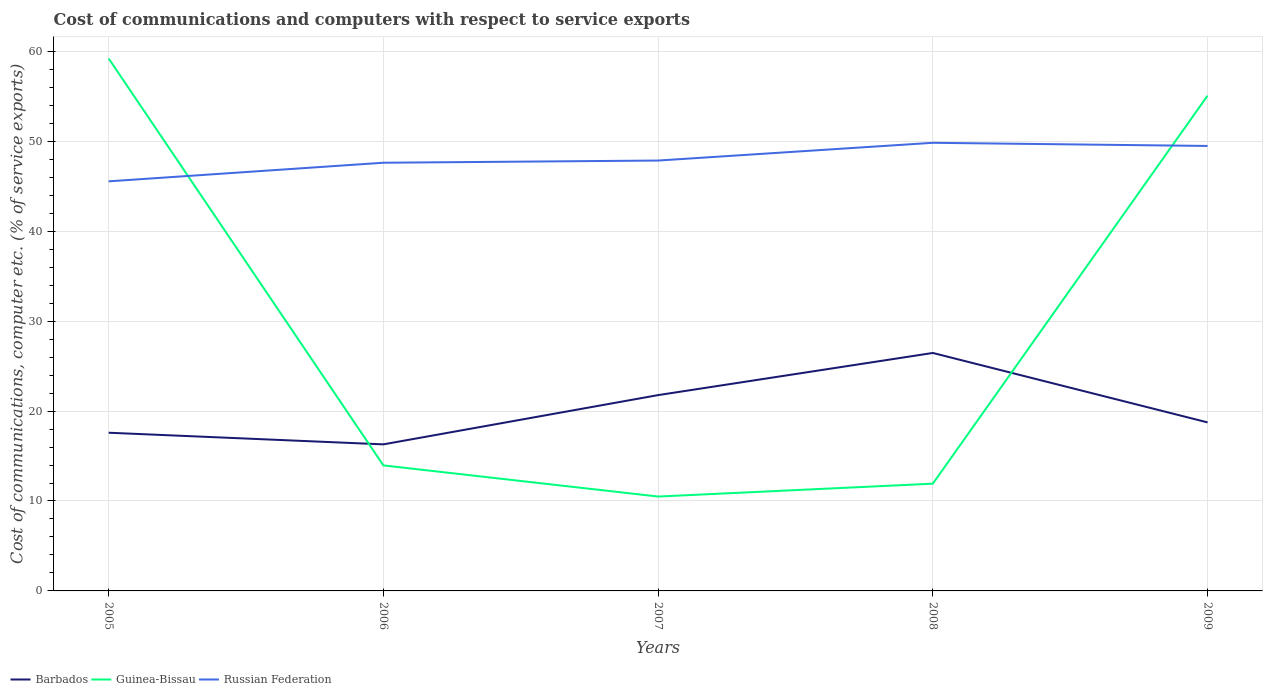How many different coloured lines are there?
Provide a succinct answer. 3. Across all years, what is the maximum cost of communications and computers in Guinea-Bissau?
Your response must be concise. 10.49. What is the total cost of communications and computers in Guinea-Bissau in the graph?
Provide a succinct answer. -1.43. What is the difference between the highest and the second highest cost of communications and computers in Barbados?
Your answer should be very brief. 10.16. What is the difference between the highest and the lowest cost of communications and computers in Russian Federation?
Ensure brevity in your answer.  2. Is the cost of communications and computers in Russian Federation strictly greater than the cost of communications and computers in Barbados over the years?
Your response must be concise. No. How many lines are there?
Offer a terse response. 3. What is the difference between two consecutive major ticks on the Y-axis?
Offer a terse response. 10. Does the graph contain any zero values?
Provide a short and direct response. No. Where does the legend appear in the graph?
Offer a terse response. Bottom left. How many legend labels are there?
Keep it short and to the point. 3. How are the legend labels stacked?
Ensure brevity in your answer.  Horizontal. What is the title of the graph?
Ensure brevity in your answer.  Cost of communications and computers with respect to service exports. Does "Guam" appear as one of the legend labels in the graph?
Offer a very short reply. No. What is the label or title of the X-axis?
Your answer should be compact. Years. What is the label or title of the Y-axis?
Your answer should be very brief. Cost of communications, computer etc. (% of service exports). What is the Cost of communications, computer etc. (% of service exports) in Barbados in 2005?
Keep it short and to the point. 17.59. What is the Cost of communications, computer etc. (% of service exports) of Guinea-Bissau in 2005?
Offer a terse response. 59.21. What is the Cost of communications, computer etc. (% of service exports) of Russian Federation in 2005?
Make the answer very short. 45.55. What is the Cost of communications, computer etc. (% of service exports) in Barbados in 2006?
Offer a very short reply. 16.3. What is the Cost of communications, computer etc. (% of service exports) of Guinea-Bissau in 2006?
Your answer should be compact. 13.96. What is the Cost of communications, computer etc. (% of service exports) of Russian Federation in 2006?
Ensure brevity in your answer.  47.61. What is the Cost of communications, computer etc. (% of service exports) of Barbados in 2007?
Provide a short and direct response. 21.77. What is the Cost of communications, computer etc. (% of service exports) in Guinea-Bissau in 2007?
Make the answer very short. 10.49. What is the Cost of communications, computer etc. (% of service exports) of Russian Federation in 2007?
Provide a succinct answer. 47.86. What is the Cost of communications, computer etc. (% of service exports) in Barbados in 2008?
Ensure brevity in your answer.  26.46. What is the Cost of communications, computer etc. (% of service exports) of Guinea-Bissau in 2008?
Your answer should be very brief. 11.93. What is the Cost of communications, computer etc. (% of service exports) of Russian Federation in 2008?
Your response must be concise. 49.83. What is the Cost of communications, computer etc. (% of service exports) in Barbados in 2009?
Provide a succinct answer. 18.74. What is the Cost of communications, computer etc. (% of service exports) in Guinea-Bissau in 2009?
Your answer should be compact. 55.07. What is the Cost of communications, computer etc. (% of service exports) in Russian Federation in 2009?
Offer a very short reply. 49.48. Across all years, what is the maximum Cost of communications, computer etc. (% of service exports) of Barbados?
Keep it short and to the point. 26.46. Across all years, what is the maximum Cost of communications, computer etc. (% of service exports) of Guinea-Bissau?
Your answer should be compact. 59.21. Across all years, what is the maximum Cost of communications, computer etc. (% of service exports) in Russian Federation?
Your answer should be very brief. 49.83. Across all years, what is the minimum Cost of communications, computer etc. (% of service exports) of Barbados?
Offer a terse response. 16.3. Across all years, what is the minimum Cost of communications, computer etc. (% of service exports) of Guinea-Bissau?
Provide a short and direct response. 10.49. Across all years, what is the minimum Cost of communications, computer etc. (% of service exports) in Russian Federation?
Your answer should be compact. 45.55. What is the total Cost of communications, computer etc. (% of service exports) of Barbados in the graph?
Ensure brevity in your answer.  100.86. What is the total Cost of communications, computer etc. (% of service exports) in Guinea-Bissau in the graph?
Offer a terse response. 150.66. What is the total Cost of communications, computer etc. (% of service exports) of Russian Federation in the graph?
Give a very brief answer. 240.33. What is the difference between the Cost of communications, computer etc. (% of service exports) of Barbados in 2005 and that in 2006?
Give a very brief answer. 1.29. What is the difference between the Cost of communications, computer etc. (% of service exports) in Guinea-Bissau in 2005 and that in 2006?
Give a very brief answer. 45.25. What is the difference between the Cost of communications, computer etc. (% of service exports) of Russian Federation in 2005 and that in 2006?
Offer a very short reply. -2.07. What is the difference between the Cost of communications, computer etc. (% of service exports) of Barbados in 2005 and that in 2007?
Provide a short and direct response. -4.18. What is the difference between the Cost of communications, computer etc. (% of service exports) of Guinea-Bissau in 2005 and that in 2007?
Your answer should be very brief. 48.71. What is the difference between the Cost of communications, computer etc. (% of service exports) of Russian Federation in 2005 and that in 2007?
Make the answer very short. -2.31. What is the difference between the Cost of communications, computer etc. (% of service exports) of Barbados in 2005 and that in 2008?
Your answer should be very brief. -8.87. What is the difference between the Cost of communications, computer etc. (% of service exports) in Guinea-Bissau in 2005 and that in 2008?
Make the answer very short. 47.28. What is the difference between the Cost of communications, computer etc. (% of service exports) in Russian Federation in 2005 and that in 2008?
Offer a terse response. -4.28. What is the difference between the Cost of communications, computer etc. (% of service exports) in Barbados in 2005 and that in 2009?
Make the answer very short. -1.15. What is the difference between the Cost of communications, computer etc. (% of service exports) of Guinea-Bissau in 2005 and that in 2009?
Your response must be concise. 4.14. What is the difference between the Cost of communications, computer etc. (% of service exports) of Russian Federation in 2005 and that in 2009?
Provide a short and direct response. -3.93. What is the difference between the Cost of communications, computer etc. (% of service exports) of Barbados in 2006 and that in 2007?
Ensure brevity in your answer.  -5.48. What is the difference between the Cost of communications, computer etc. (% of service exports) of Guinea-Bissau in 2006 and that in 2007?
Your answer should be compact. 3.46. What is the difference between the Cost of communications, computer etc. (% of service exports) in Russian Federation in 2006 and that in 2007?
Your response must be concise. -0.24. What is the difference between the Cost of communications, computer etc. (% of service exports) in Barbados in 2006 and that in 2008?
Offer a very short reply. -10.16. What is the difference between the Cost of communications, computer etc. (% of service exports) of Guinea-Bissau in 2006 and that in 2008?
Give a very brief answer. 2.03. What is the difference between the Cost of communications, computer etc. (% of service exports) in Russian Federation in 2006 and that in 2008?
Give a very brief answer. -2.22. What is the difference between the Cost of communications, computer etc. (% of service exports) in Barbados in 2006 and that in 2009?
Keep it short and to the point. -2.44. What is the difference between the Cost of communications, computer etc. (% of service exports) of Guinea-Bissau in 2006 and that in 2009?
Your answer should be compact. -41.11. What is the difference between the Cost of communications, computer etc. (% of service exports) of Russian Federation in 2006 and that in 2009?
Your answer should be compact. -1.87. What is the difference between the Cost of communications, computer etc. (% of service exports) in Barbados in 2007 and that in 2008?
Offer a terse response. -4.69. What is the difference between the Cost of communications, computer etc. (% of service exports) in Guinea-Bissau in 2007 and that in 2008?
Provide a succinct answer. -1.43. What is the difference between the Cost of communications, computer etc. (% of service exports) of Russian Federation in 2007 and that in 2008?
Provide a short and direct response. -1.97. What is the difference between the Cost of communications, computer etc. (% of service exports) of Barbados in 2007 and that in 2009?
Make the answer very short. 3.03. What is the difference between the Cost of communications, computer etc. (% of service exports) in Guinea-Bissau in 2007 and that in 2009?
Keep it short and to the point. -44.58. What is the difference between the Cost of communications, computer etc. (% of service exports) of Russian Federation in 2007 and that in 2009?
Your answer should be very brief. -1.62. What is the difference between the Cost of communications, computer etc. (% of service exports) in Barbados in 2008 and that in 2009?
Make the answer very short. 7.72. What is the difference between the Cost of communications, computer etc. (% of service exports) in Guinea-Bissau in 2008 and that in 2009?
Make the answer very short. -43.15. What is the difference between the Cost of communications, computer etc. (% of service exports) in Russian Federation in 2008 and that in 2009?
Keep it short and to the point. 0.35. What is the difference between the Cost of communications, computer etc. (% of service exports) in Barbados in 2005 and the Cost of communications, computer etc. (% of service exports) in Guinea-Bissau in 2006?
Your answer should be very brief. 3.63. What is the difference between the Cost of communications, computer etc. (% of service exports) of Barbados in 2005 and the Cost of communications, computer etc. (% of service exports) of Russian Federation in 2006?
Provide a succinct answer. -30.02. What is the difference between the Cost of communications, computer etc. (% of service exports) of Guinea-Bissau in 2005 and the Cost of communications, computer etc. (% of service exports) of Russian Federation in 2006?
Offer a terse response. 11.59. What is the difference between the Cost of communications, computer etc. (% of service exports) in Barbados in 2005 and the Cost of communications, computer etc. (% of service exports) in Guinea-Bissau in 2007?
Make the answer very short. 7.1. What is the difference between the Cost of communications, computer etc. (% of service exports) of Barbados in 2005 and the Cost of communications, computer etc. (% of service exports) of Russian Federation in 2007?
Offer a terse response. -30.27. What is the difference between the Cost of communications, computer etc. (% of service exports) in Guinea-Bissau in 2005 and the Cost of communications, computer etc. (% of service exports) in Russian Federation in 2007?
Keep it short and to the point. 11.35. What is the difference between the Cost of communications, computer etc. (% of service exports) of Barbados in 2005 and the Cost of communications, computer etc. (% of service exports) of Guinea-Bissau in 2008?
Provide a succinct answer. 5.67. What is the difference between the Cost of communications, computer etc. (% of service exports) in Barbados in 2005 and the Cost of communications, computer etc. (% of service exports) in Russian Federation in 2008?
Keep it short and to the point. -32.24. What is the difference between the Cost of communications, computer etc. (% of service exports) of Guinea-Bissau in 2005 and the Cost of communications, computer etc. (% of service exports) of Russian Federation in 2008?
Offer a terse response. 9.38. What is the difference between the Cost of communications, computer etc. (% of service exports) of Barbados in 2005 and the Cost of communications, computer etc. (% of service exports) of Guinea-Bissau in 2009?
Your answer should be compact. -37.48. What is the difference between the Cost of communications, computer etc. (% of service exports) of Barbados in 2005 and the Cost of communications, computer etc. (% of service exports) of Russian Federation in 2009?
Provide a succinct answer. -31.89. What is the difference between the Cost of communications, computer etc. (% of service exports) in Guinea-Bissau in 2005 and the Cost of communications, computer etc. (% of service exports) in Russian Federation in 2009?
Provide a succinct answer. 9.73. What is the difference between the Cost of communications, computer etc. (% of service exports) in Barbados in 2006 and the Cost of communications, computer etc. (% of service exports) in Guinea-Bissau in 2007?
Your answer should be compact. 5.8. What is the difference between the Cost of communications, computer etc. (% of service exports) in Barbados in 2006 and the Cost of communications, computer etc. (% of service exports) in Russian Federation in 2007?
Offer a very short reply. -31.56. What is the difference between the Cost of communications, computer etc. (% of service exports) in Guinea-Bissau in 2006 and the Cost of communications, computer etc. (% of service exports) in Russian Federation in 2007?
Offer a terse response. -33.9. What is the difference between the Cost of communications, computer etc. (% of service exports) in Barbados in 2006 and the Cost of communications, computer etc. (% of service exports) in Guinea-Bissau in 2008?
Give a very brief answer. 4.37. What is the difference between the Cost of communications, computer etc. (% of service exports) of Barbados in 2006 and the Cost of communications, computer etc. (% of service exports) of Russian Federation in 2008?
Make the answer very short. -33.53. What is the difference between the Cost of communications, computer etc. (% of service exports) in Guinea-Bissau in 2006 and the Cost of communications, computer etc. (% of service exports) in Russian Federation in 2008?
Make the answer very short. -35.87. What is the difference between the Cost of communications, computer etc. (% of service exports) of Barbados in 2006 and the Cost of communications, computer etc. (% of service exports) of Guinea-Bissau in 2009?
Make the answer very short. -38.78. What is the difference between the Cost of communications, computer etc. (% of service exports) in Barbados in 2006 and the Cost of communications, computer etc. (% of service exports) in Russian Federation in 2009?
Provide a succinct answer. -33.18. What is the difference between the Cost of communications, computer etc. (% of service exports) in Guinea-Bissau in 2006 and the Cost of communications, computer etc. (% of service exports) in Russian Federation in 2009?
Ensure brevity in your answer.  -35.52. What is the difference between the Cost of communications, computer etc. (% of service exports) of Barbados in 2007 and the Cost of communications, computer etc. (% of service exports) of Guinea-Bissau in 2008?
Provide a short and direct response. 9.85. What is the difference between the Cost of communications, computer etc. (% of service exports) in Barbados in 2007 and the Cost of communications, computer etc. (% of service exports) in Russian Federation in 2008?
Make the answer very short. -28.06. What is the difference between the Cost of communications, computer etc. (% of service exports) in Guinea-Bissau in 2007 and the Cost of communications, computer etc. (% of service exports) in Russian Federation in 2008?
Provide a succinct answer. -39.34. What is the difference between the Cost of communications, computer etc. (% of service exports) in Barbados in 2007 and the Cost of communications, computer etc. (% of service exports) in Guinea-Bissau in 2009?
Ensure brevity in your answer.  -33.3. What is the difference between the Cost of communications, computer etc. (% of service exports) in Barbados in 2007 and the Cost of communications, computer etc. (% of service exports) in Russian Federation in 2009?
Your answer should be very brief. -27.71. What is the difference between the Cost of communications, computer etc. (% of service exports) in Guinea-Bissau in 2007 and the Cost of communications, computer etc. (% of service exports) in Russian Federation in 2009?
Your answer should be compact. -38.99. What is the difference between the Cost of communications, computer etc. (% of service exports) of Barbados in 2008 and the Cost of communications, computer etc. (% of service exports) of Guinea-Bissau in 2009?
Your response must be concise. -28.61. What is the difference between the Cost of communications, computer etc. (% of service exports) of Barbados in 2008 and the Cost of communications, computer etc. (% of service exports) of Russian Federation in 2009?
Provide a succinct answer. -23.02. What is the difference between the Cost of communications, computer etc. (% of service exports) in Guinea-Bissau in 2008 and the Cost of communications, computer etc. (% of service exports) in Russian Federation in 2009?
Ensure brevity in your answer.  -37.55. What is the average Cost of communications, computer etc. (% of service exports) in Barbados per year?
Provide a succinct answer. 20.17. What is the average Cost of communications, computer etc. (% of service exports) in Guinea-Bissau per year?
Offer a very short reply. 30.13. What is the average Cost of communications, computer etc. (% of service exports) of Russian Federation per year?
Your answer should be compact. 48.07. In the year 2005, what is the difference between the Cost of communications, computer etc. (% of service exports) of Barbados and Cost of communications, computer etc. (% of service exports) of Guinea-Bissau?
Your answer should be very brief. -41.62. In the year 2005, what is the difference between the Cost of communications, computer etc. (% of service exports) in Barbados and Cost of communications, computer etc. (% of service exports) in Russian Federation?
Offer a very short reply. -27.96. In the year 2005, what is the difference between the Cost of communications, computer etc. (% of service exports) in Guinea-Bissau and Cost of communications, computer etc. (% of service exports) in Russian Federation?
Offer a terse response. 13.66. In the year 2006, what is the difference between the Cost of communications, computer etc. (% of service exports) in Barbados and Cost of communications, computer etc. (% of service exports) in Guinea-Bissau?
Provide a succinct answer. 2.34. In the year 2006, what is the difference between the Cost of communications, computer etc. (% of service exports) of Barbados and Cost of communications, computer etc. (% of service exports) of Russian Federation?
Your response must be concise. -31.32. In the year 2006, what is the difference between the Cost of communications, computer etc. (% of service exports) in Guinea-Bissau and Cost of communications, computer etc. (% of service exports) in Russian Federation?
Make the answer very short. -33.66. In the year 2007, what is the difference between the Cost of communications, computer etc. (% of service exports) in Barbados and Cost of communications, computer etc. (% of service exports) in Guinea-Bissau?
Keep it short and to the point. 11.28. In the year 2007, what is the difference between the Cost of communications, computer etc. (% of service exports) of Barbados and Cost of communications, computer etc. (% of service exports) of Russian Federation?
Offer a very short reply. -26.08. In the year 2007, what is the difference between the Cost of communications, computer etc. (% of service exports) of Guinea-Bissau and Cost of communications, computer etc. (% of service exports) of Russian Federation?
Keep it short and to the point. -37.36. In the year 2008, what is the difference between the Cost of communications, computer etc. (% of service exports) of Barbados and Cost of communications, computer etc. (% of service exports) of Guinea-Bissau?
Make the answer very short. 14.54. In the year 2008, what is the difference between the Cost of communications, computer etc. (% of service exports) of Barbados and Cost of communications, computer etc. (% of service exports) of Russian Federation?
Make the answer very short. -23.37. In the year 2008, what is the difference between the Cost of communications, computer etc. (% of service exports) of Guinea-Bissau and Cost of communications, computer etc. (% of service exports) of Russian Federation?
Keep it short and to the point. -37.9. In the year 2009, what is the difference between the Cost of communications, computer etc. (% of service exports) of Barbados and Cost of communications, computer etc. (% of service exports) of Guinea-Bissau?
Your answer should be compact. -36.33. In the year 2009, what is the difference between the Cost of communications, computer etc. (% of service exports) in Barbados and Cost of communications, computer etc. (% of service exports) in Russian Federation?
Offer a terse response. -30.74. In the year 2009, what is the difference between the Cost of communications, computer etc. (% of service exports) of Guinea-Bissau and Cost of communications, computer etc. (% of service exports) of Russian Federation?
Your answer should be very brief. 5.59. What is the ratio of the Cost of communications, computer etc. (% of service exports) of Barbados in 2005 to that in 2006?
Offer a terse response. 1.08. What is the ratio of the Cost of communications, computer etc. (% of service exports) of Guinea-Bissau in 2005 to that in 2006?
Keep it short and to the point. 4.24. What is the ratio of the Cost of communications, computer etc. (% of service exports) of Russian Federation in 2005 to that in 2006?
Offer a terse response. 0.96. What is the ratio of the Cost of communications, computer etc. (% of service exports) in Barbados in 2005 to that in 2007?
Offer a terse response. 0.81. What is the ratio of the Cost of communications, computer etc. (% of service exports) in Guinea-Bissau in 2005 to that in 2007?
Provide a succinct answer. 5.64. What is the ratio of the Cost of communications, computer etc. (% of service exports) of Russian Federation in 2005 to that in 2007?
Make the answer very short. 0.95. What is the ratio of the Cost of communications, computer etc. (% of service exports) of Barbados in 2005 to that in 2008?
Ensure brevity in your answer.  0.66. What is the ratio of the Cost of communications, computer etc. (% of service exports) of Guinea-Bissau in 2005 to that in 2008?
Offer a very short reply. 4.96. What is the ratio of the Cost of communications, computer etc. (% of service exports) in Russian Federation in 2005 to that in 2008?
Make the answer very short. 0.91. What is the ratio of the Cost of communications, computer etc. (% of service exports) in Barbados in 2005 to that in 2009?
Give a very brief answer. 0.94. What is the ratio of the Cost of communications, computer etc. (% of service exports) of Guinea-Bissau in 2005 to that in 2009?
Your answer should be very brief. 1.08. What is the ratio of the Cost of communications, computer etc. (% of service exports) in Russian Federation in 2005 to that in 2009?
Your answer should be very brief. 0.92. What is the ratio of the Cost of communications, computer etc. (% of service exports) of Barbados in 2006 to that in 2007?
Your response must be concise. 0.75. What is the ratio of the Cost of communications, computer etc. (% of service exports) of Guinea-Bissau in 2006 to that in 2007?
Your response must be concise. 1.33. What is the ratio of the Cost of communications, computer etc. (% of service exports) of Barbados in 2006 to that in 2008?
Your response must be concise. 0.62. What is the ratio of the Cost of communications, computer etc. (% of service exports) in Guinea-Bissau in 2006 to that in 2008?
Provide a short and direct response. 1.17. What is the ratio of the Cost of communications, computer etc. (% of service exports) of Russian Federation in 2006 to that in 2008?
Your answer should be very brief. 0.96. What is the ratio of the Cost of communications, computer etc. (% of service exports) in Barbados in 2006 to that in 2009?
Your response must be concise. 0.87. What is the ratio of the Cost of communications, computer etc. (% of service exports) of Guinea-Bissau in 2006 to that in 2009?
Give a very brief answer. 0.25. What is the ratio of the Cost of communications, computer etc. (% of service exports) in Russian Federation in 2006 to that in 2009?
Your answer should be compact. 0.96. What is the ratio of the Cost of communications, computer etc. (% of service exports) of Barbados in 2007 to that in 2008?
Provide a short and direct response. 0.82. What is the ratio of the Cost of communications, computer etc. (% of service exports) in Guinea-Bissau in 2007 to that in 2008?
Ensure brevity in your answer.  0.88. What is the ratio of the Cost of communications, computer etc. (% of service exports) in Russian Federation in 2007 to that in 2008?
Make the answer very short. 0.96. What is the ratio of the Cost of communications, computer etc. (% of service exports) in Barbados in 2007 to that in 2009?
Offer a terse response. 1.16. What is the ratio of the Cost of communications, computer etc. (% of service exports) in Guinea-Bissau in 2007 to that in 2009?
Your response must be concise. 0.19. What is the ratio of the Cost of communications, computer etc. (% of service exports) in Russian Federation in 2007 to that in 2009?
Give a very brief answer. 0.97. What is the ratio of the Cost of communications, computer etc. (% of service exports) of Barbados in 2008 to that in 2009?
Ensure brevity in your answer.  1.41. What is the ratio of the Cost of communications, computer etc. (% of service exports) in Guinea-Bissau in 2008 to that in 2009?
Keep it short and to the point. 0.22. What is the ratio of the Cost of communications, computer etc. (% of service exports) in Russian Federation in 2008 to that in 2009?
Offer a very short reply. 1.01. What is the difference between the highest and the second highest Cost of communications, computer etc. (% of service exports) in Barbados?
Your answer should be compact. 4.69. What is the difference between the highest and the second highest Cost of communications, computer etc. (% of service exports) in Guinea-Bissau?
Offer a terse response. 4.14. What is the difference between the highest and the second highest Cost of communications, computer etc. (% of service exports) in Russian Federation?
Your response must be concise. 0.35. What is the difference between the highest and the lowest Cost of communications, computer etc. (% of service exports) of Barbados?
Offer a very short reply. 10.16. What is the difference between the highest and the lowest Cost of communications, computer etc. (% of service exports) of Guinea-Bissau?
Your response must be concise. 48.71. What is the difference between the highest and the lowest Cost of communications, computer etc. (% of service exports) in Russian Federation?
Your response must be concise. 4.28. 